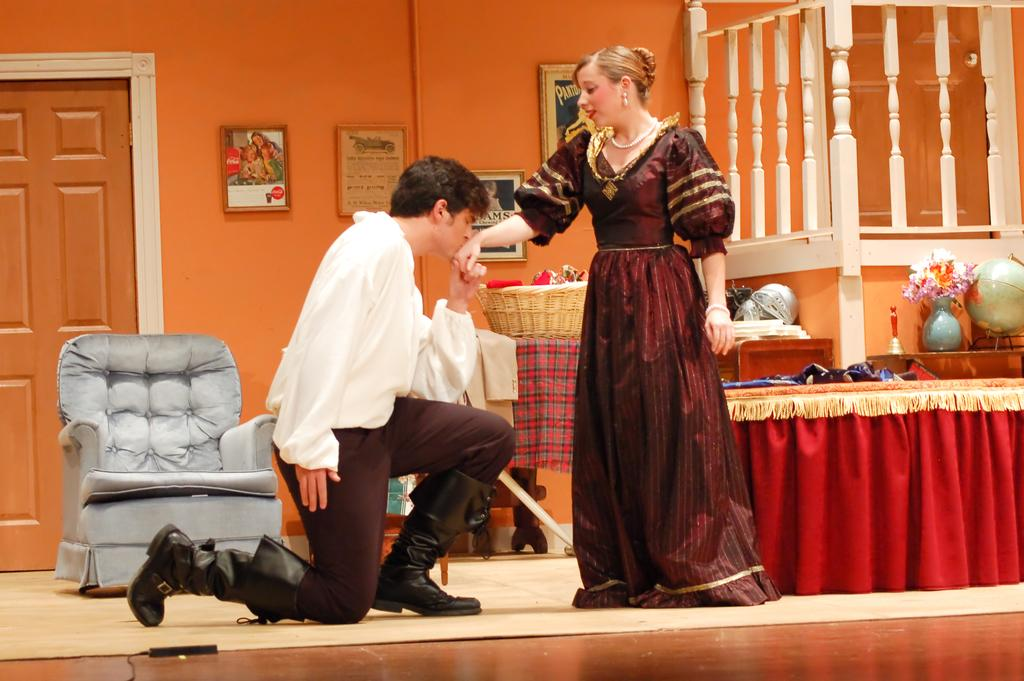What is the man in the image doing? The man is standing on his knees and kissing a girl's hand in the image. Can you describe the background of the image? There is a chair, a door, and frames on the wall in the background of the image. What type of record is the man breaking in the image? There is no record being broken in the image. 